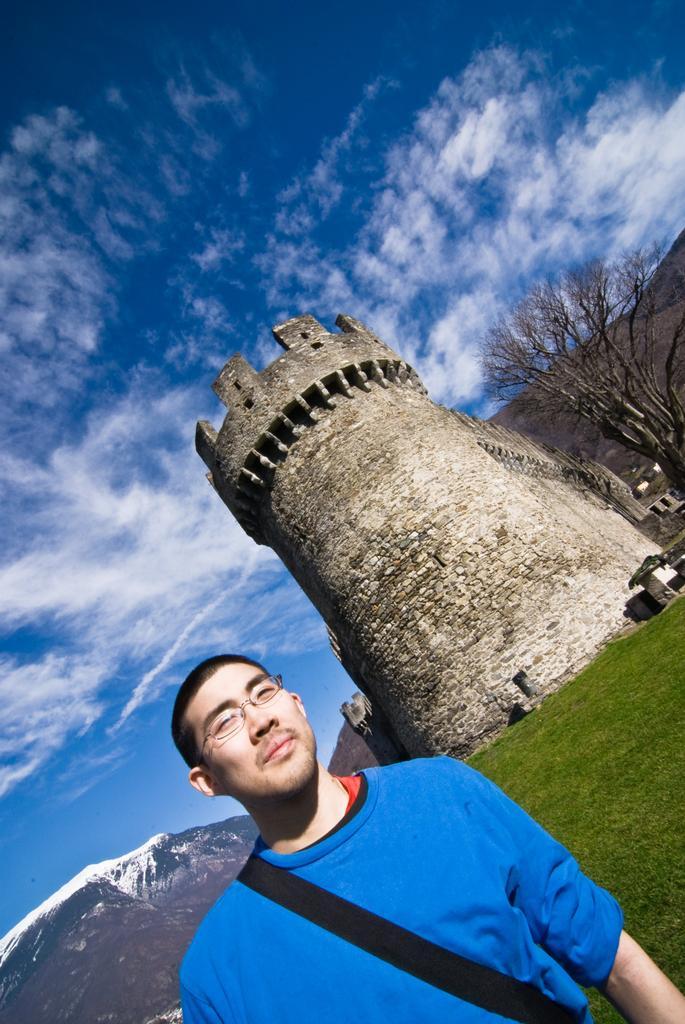In one or two sentences, can you explain what this image depicts? In the foreground of this image, there is a man in blue T shirt and wearing a bag. In the background, there is a castle, grass, a tree, few mountains, sky and the cloud. 